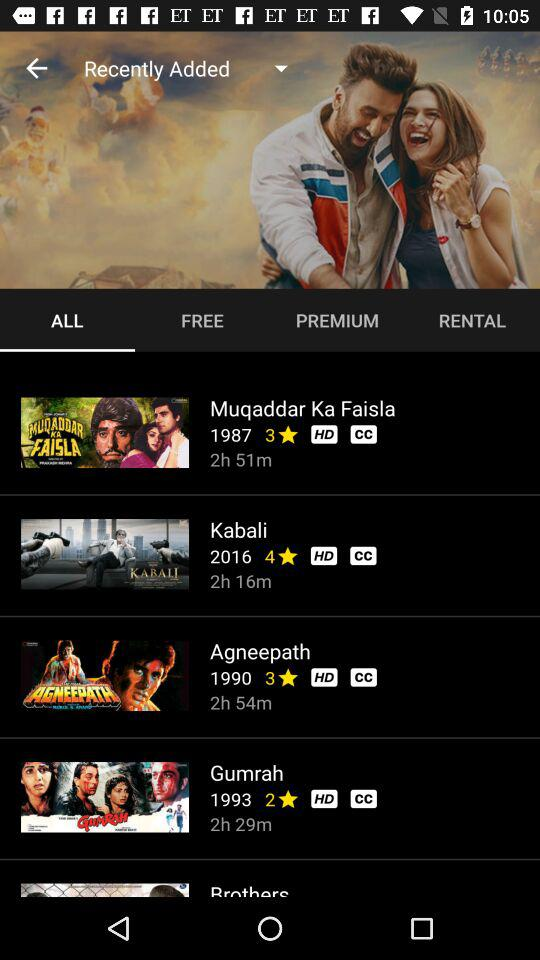What is the rating of the movie "Gumrah"? The rating of the movie is 2 stars. 